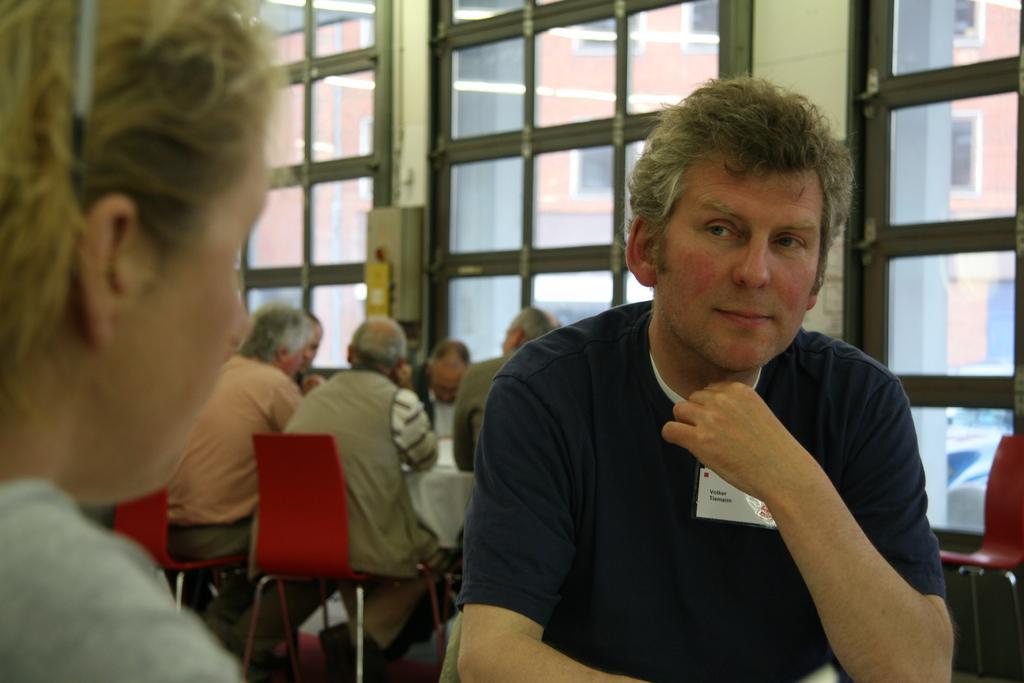Could you give a brief overview of what you see in this image? In this image I can see a person wearing a black t-shirt is sitting on a chair and to the left of the image I can see another person. In the background I can see people sitting on chairs in front of a table and few Windows through which I can see a building and few vehicles. 